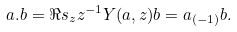Convert formula to latex. <formula><loc_0><loc_0><loc_500><loc_500>a . b = \Re s _ { z } z ^ { - 1 } Y ( a , z ) b = a _ { ( - 1 ) } b .</formula> 